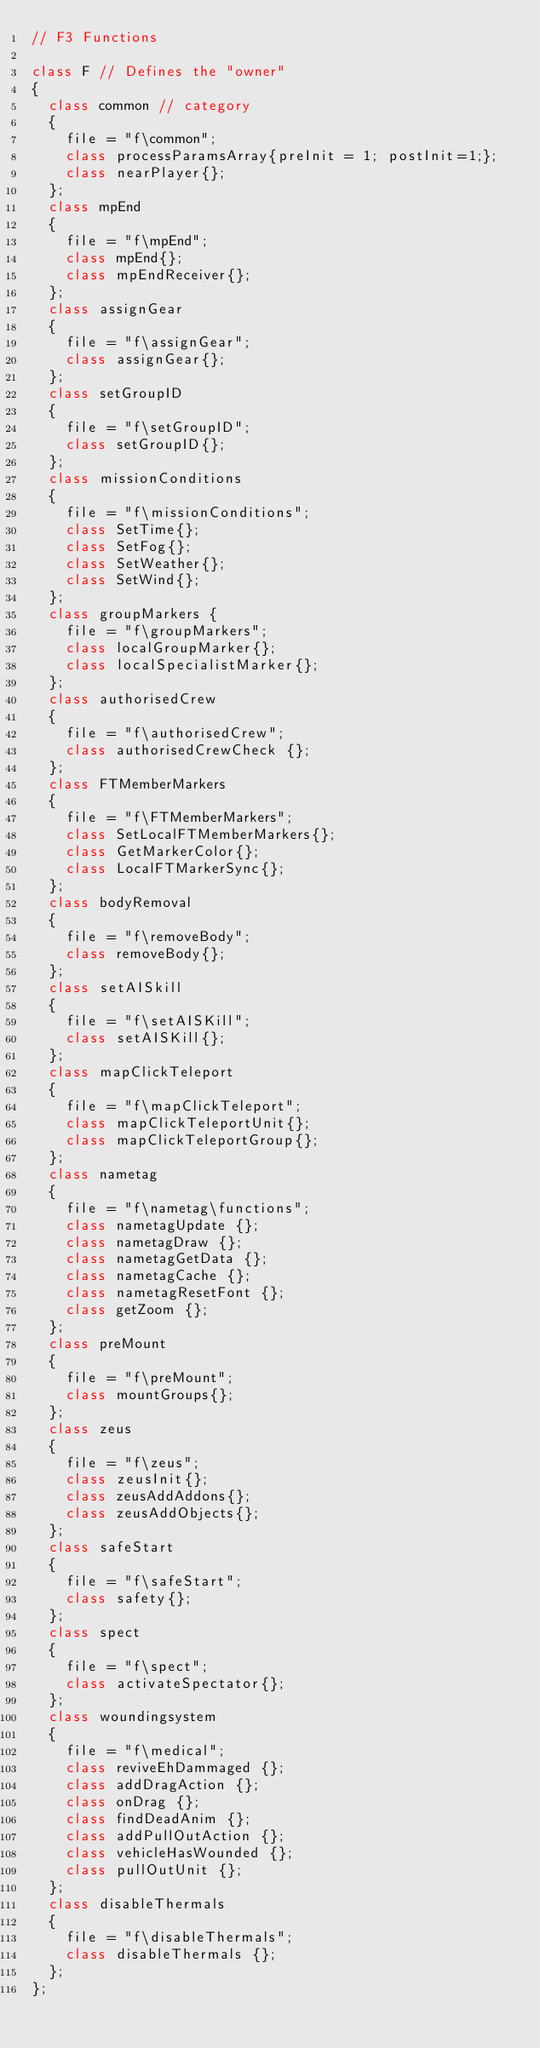Convert code to text. <code><loc_0><loc_0><loc_500><loc_500><_C++_>// F3 Functions

class F // Defines the "owner"
{
	class common // category
	{
		file = "f\common";
		class processParamsArray{preInit = 1; postInit=1;};
		class nearPlayer{};
	};
	class mpEnd
	{
		file = "f\mpEnd";
		class mpEnd{};
		class mpEndReceiver{};
	};
	class assignGear
	{
		file = "f\assignGear";
		class assignGear{};
	};
	class setGroupID
	{
		file = "f\setGroupID";
		class setGroupID{};
	};
	class missionConditions
	{
		file = "f\missionConditions";
		class SetTime{};
		class SetFog{};
		class SetWeather{};
		class SetWind{};
	};
	class groupMarkers {
		file = "f\groupMarkers";
		class localGroupMarker{};
		class localSpecialistMarker{};
	};
	class authorisedCrew
	{
		file = "f\authorisedCrew";
		class authorisedCrewCheck {};
	};
	class FTMemberMarkers
	{
		file = "f\FTMemberMarkers";
		class SetLocalFTMemberMarkers{};
		class GetMarkerColor{};
		class LocalFTMarkerSync{};
	};
	class bodyRemoval
	{
		file = "f\removeBody";
		class removeBody{};
	};
	class setAISkill
	{
		file = "f\setAISKill";
		class setAISKill{};
	};
	class mapClickTeleport
	{
		file = "f\mapClickTeleport";
		class mapClickTeleportUnit{};
		class mapClickTeleportGroup{};
	};
	class nametag
	{
		file = "f\nametag\functions";
		class nametagUpdate {};
		class nametagDraw {};
		class nametagGetData {};
		class nametagCache {};
		class nametagResetFont {};
		class getZoom {};
	};
	class preMount
	{
		file = "f\preMount";
		class mountGroups{};
	};
	class zeus
	{
		file = "f\zeus";
		class zeusInit{};
		class zeusAddAddons{};
		class zeusAddObjects{};
	};
	class safeStart
	{
		file = "f\safeStart";
		class safety{};
	};
	class spect
	{
		file = "f\spect";
		class activateSpectator{};
	};
	class woundingsystem
	{
		file = "f\medical";
		class reviveEhDammaged {};
		class addDragAction {};
		class onDrag {};
		class findDeadAnim {};
		class addPullOutAction {};
		class vehicleHasWounded {};
		class pullOutUnit {};
	};
	class disableThermals
	{
		file = "f\disableThermals";
		class disableThermals {};
	};
};
</code> 